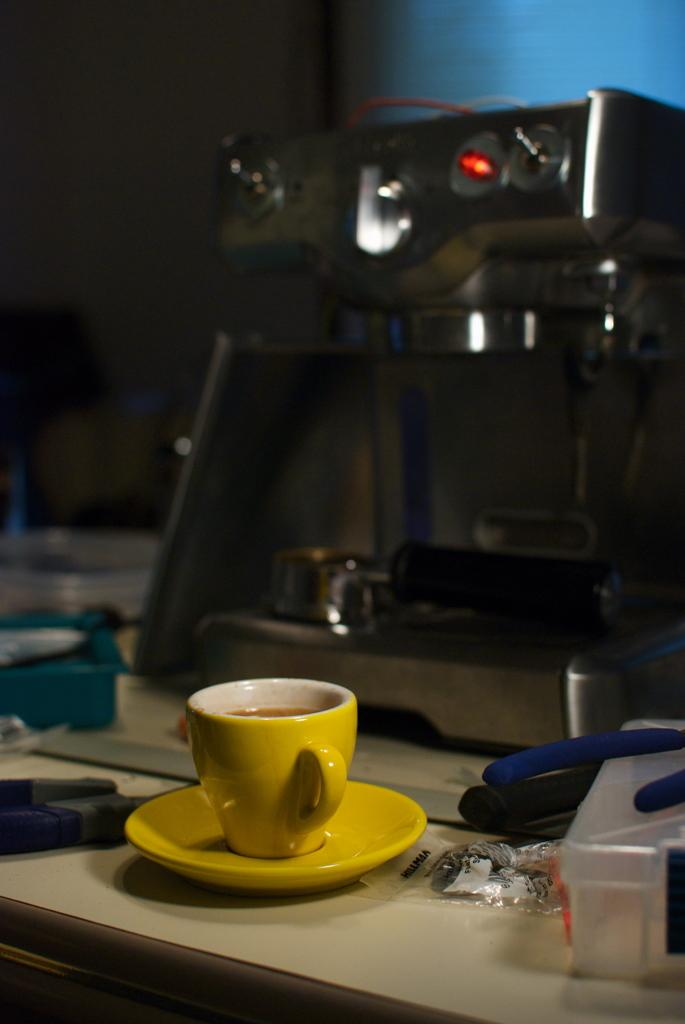What is one of the objects visible on the table in the image? There is a cup in the image. What is another object that can be seen on the table in the image? There is a saucer in the image. What type of device is present in the image? There is an electronic machine in the image. Can you describe any other objects that are on the table in the image? There are other objects on the table in the image. How does the hand interact with the cup in the image? There is no hand visible in the image; it only shows a cup, a saucer, an electronic machine, and other objects on the table. What type of respect is being shown to the electronic machine in the image? There is no indication of respect or any other emotion being shown towards the electronic machine in the image. 